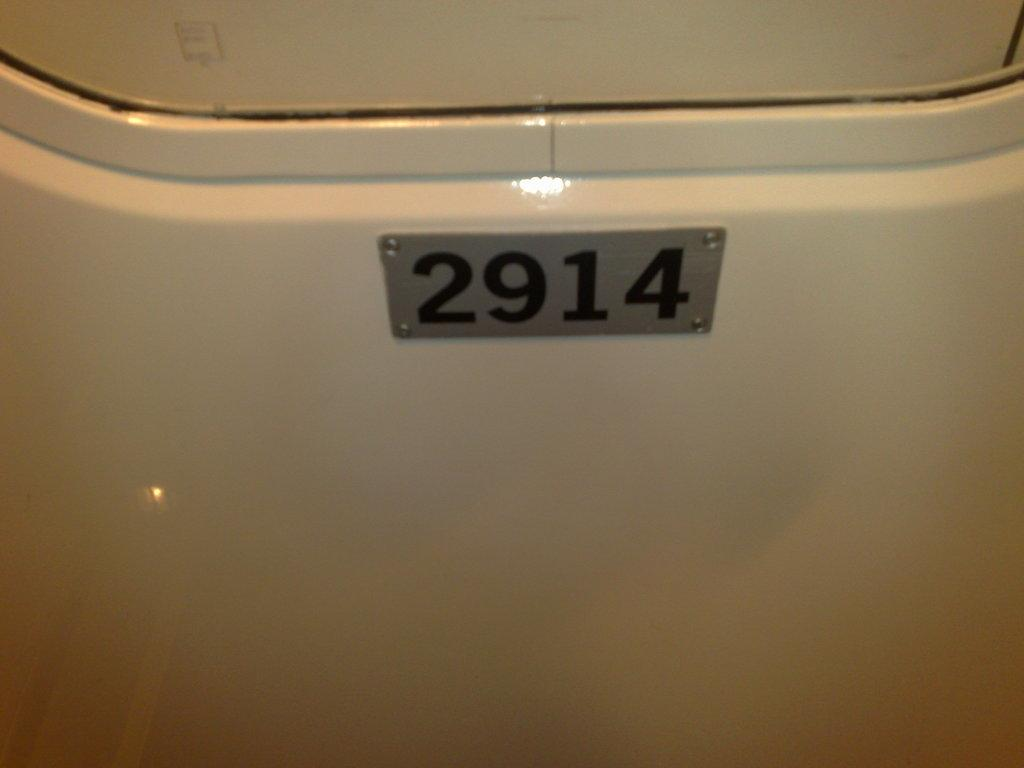What is the primary color of the surface in the image? The surface in the image is white. What can be found in the center of the picture? There is a number plate in the center of the picture. What type of coat is the person wearing in the image? There is no person or coat present in the image; it only features a white surface and a number plate. 